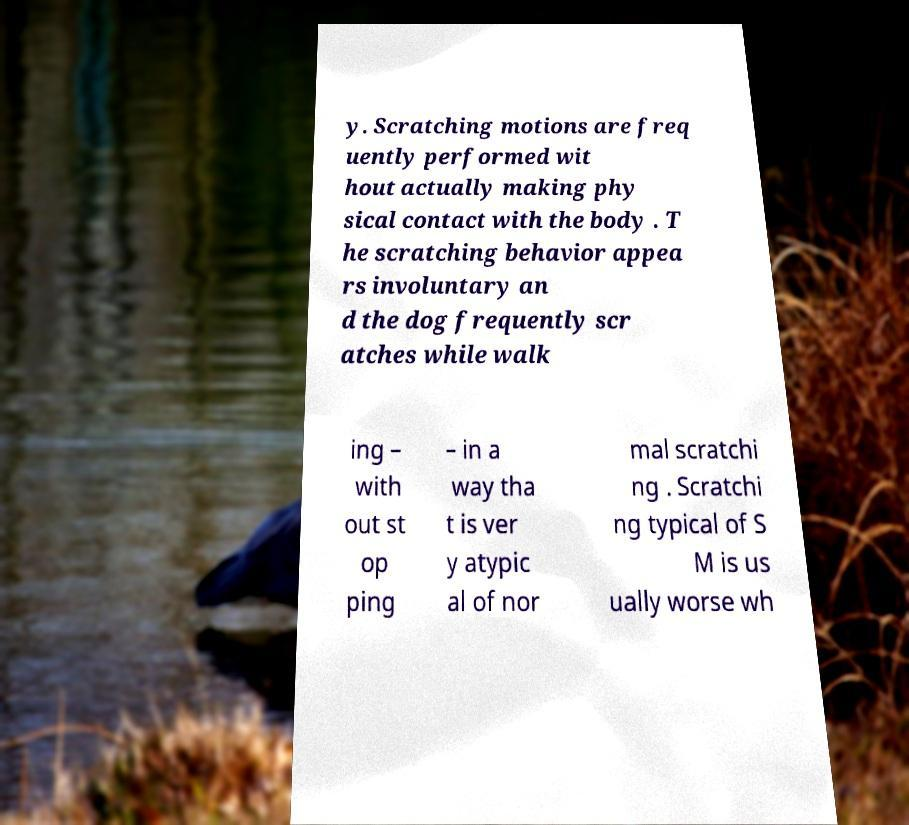Could you assist in decoding the text presented in this image and type it out clearly? y. Scratching motions are freq uently performed wit hout actually making phy sical contact with the body . T he scratching behavior appea rs involuntary an d the dog frequently scr atches while walk ing – with out st op ping – in a way tha t is ver y atypic al of nor mal scratchi ng . Scratchi ng typical of S M is us ually worse wh 